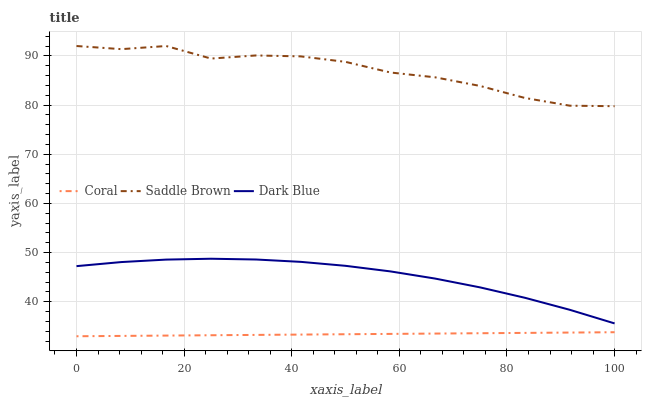Does Coral have the minimum area under the curve?
Answer yes or no. Yes. Does Saddle Brown have the maximum area under the curve?
Answer yes or no. Yes. Does Saddle Brown have the minimum area under the curve?
Answer yes or no. No. Does Coral have the maximum area under the curve?
Answer yes or no. No. Is Coral the smoothest?
Answer yes or no. Yes. Is Saddle Brown the roughest?
Answer yes or no. Yes. Is Saddle Brown the smoothest?
Answer yes or no. No. Is Coral the roughest?
Answer yes or no. No. Does Coral have the lowest value?
Answer yes or no. Yes. Does Saddle Brown have the lowest value?
Answer yes or no. No. Does Saddle Brown have the highest value?
Answer yes or no. Yes. Does Coral have the highest value?
Answer yes or no. No. Is Coral less than Dark Blue?
Answer yes or no. Yes. Is Saddle Brown greater than Coral?
Answer yes or no. Yes. Does Coral intersect Dark Blue?
Answer yes or no. No. 